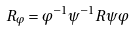<formula> <loc_0><loc_0><loc_500><loc_500>R _ { \varphi } = \varphi ^ { - 1 } \psi ^ { - 1 } R \psi \varphi</formula> 